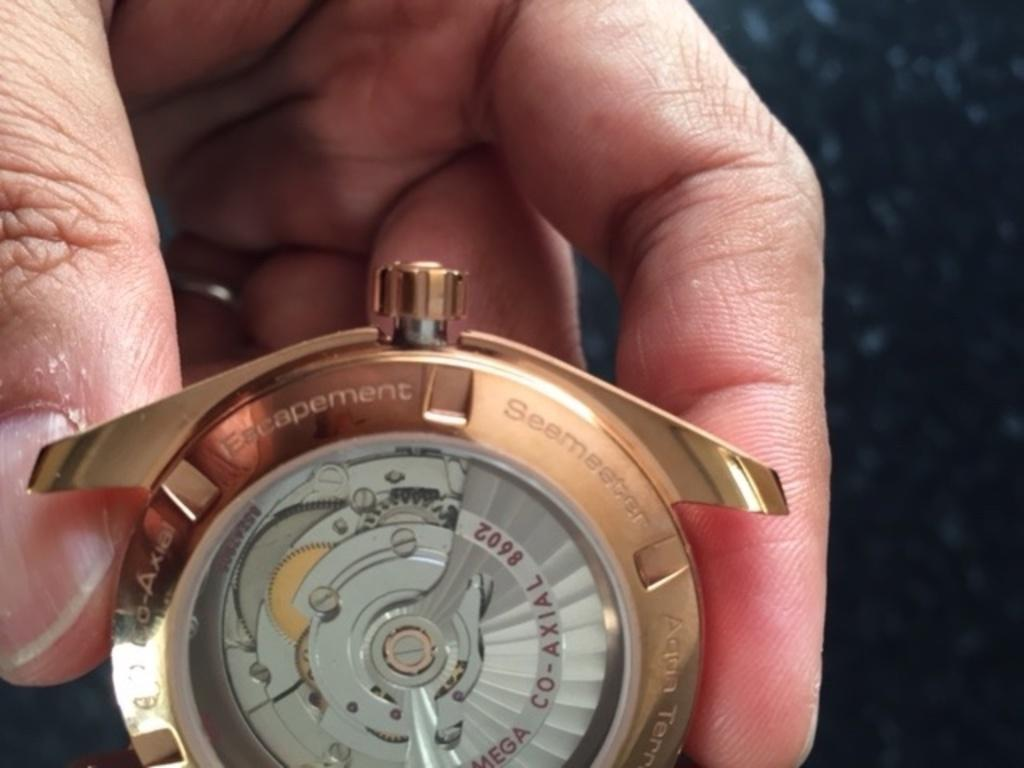<image>
Provide a brief description of the given image. the word escapement that is on a clock 